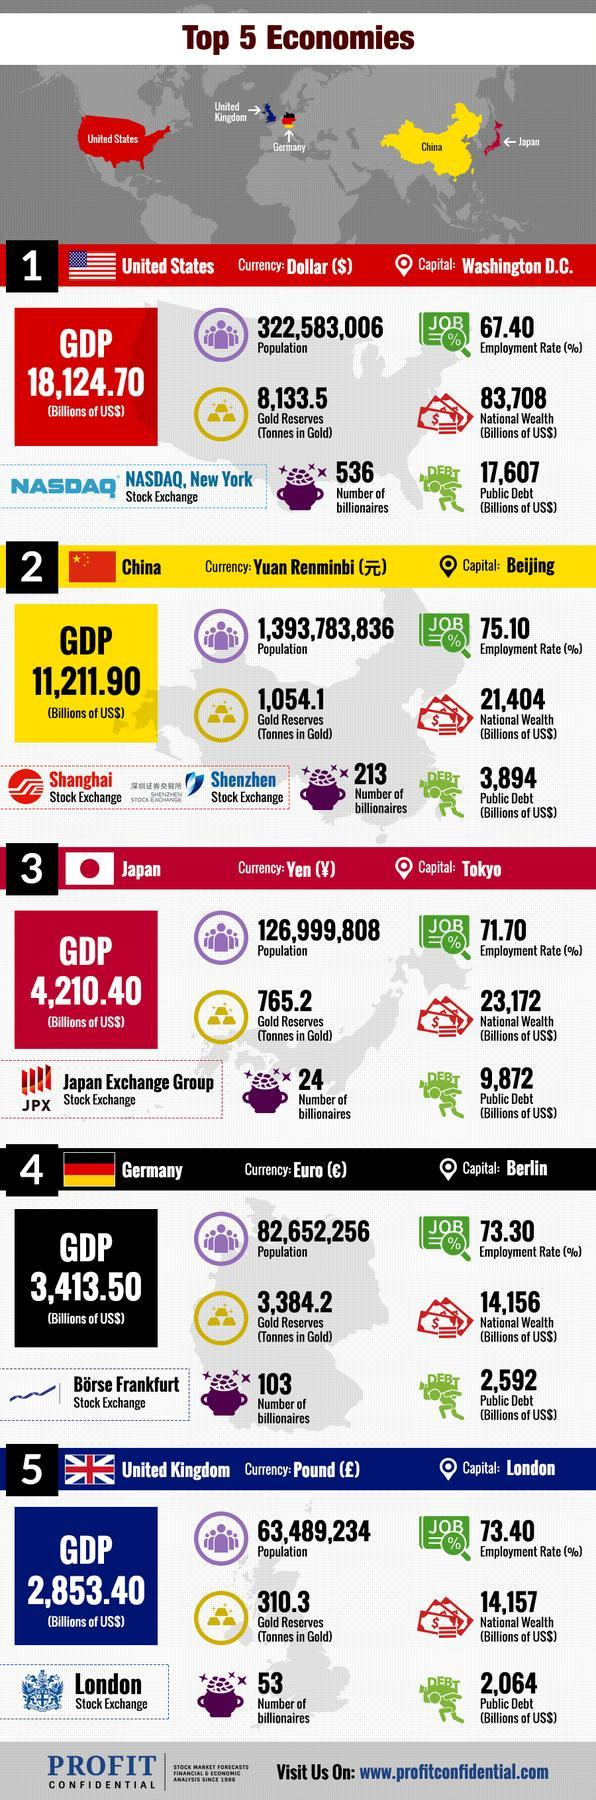What is the number of billionaires in the United States?
Answer the question with a short phrase. 536 Which country has two stock exchanges? China Which one has the highest employment rate-United States, China? China What is the number of billionaires in China? 213 Which country has the highest employment rate? china What is the GDP of the United States? 18,124.70 What is the name of the stock exchange of Germany? Borse Frankfurt What is the population of the United states? 322,583,006 Which country has the lowest number of billionaires? Japan Which country has the lowest employment rate? United States 